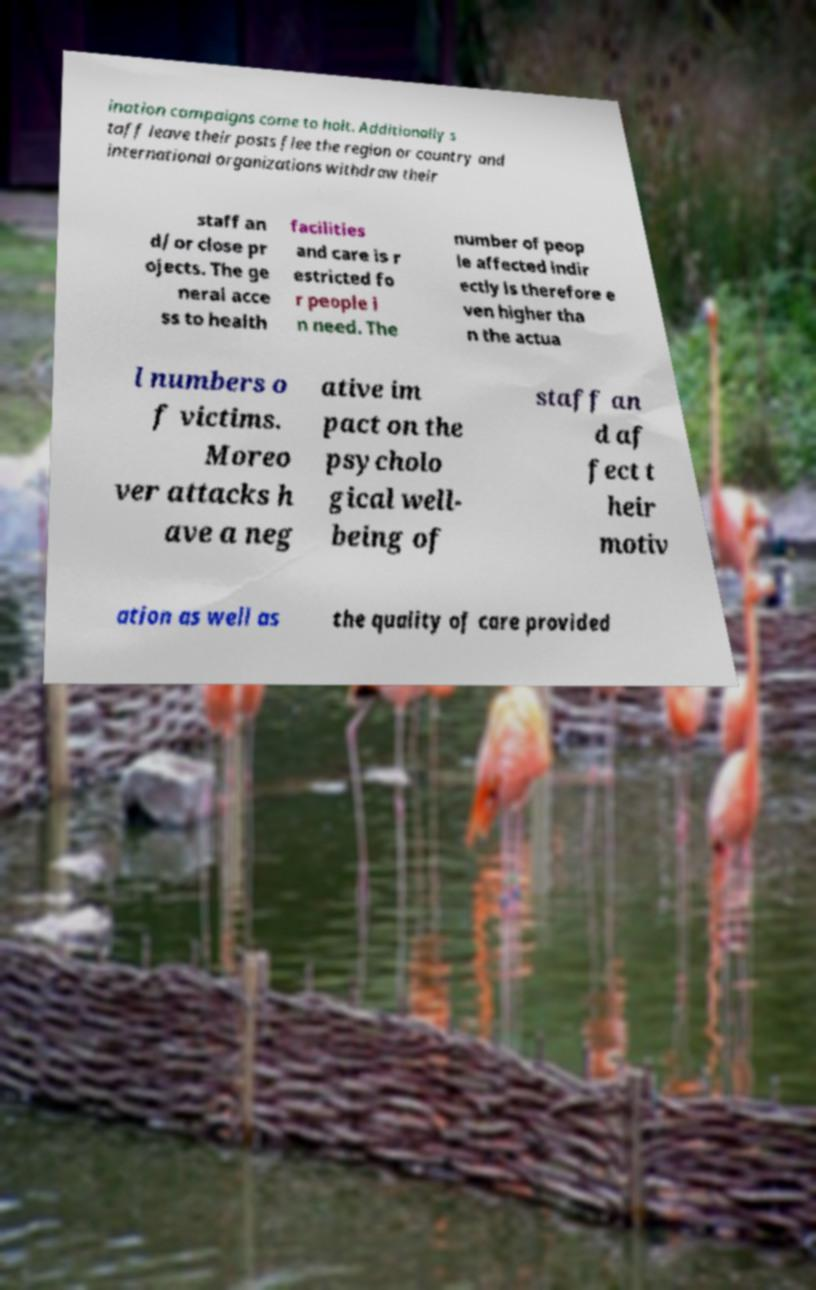Could you extract and type out the text from this image? ination campaigns come to halt. Additionally s taff leave their posts flee the region or country and international organizations withdraw their staff an d/ or close pr ojects. The ge neral acce ss to health facilities and care is r estricted fo r people i n need. The number of peop le affected indir ectly is therefore e ven higher tha n the actua l numbers o f victims. Moreo ver attacks h ave a neg ative im pact on the psycholo gical well- being of staff an d af fect t heir motiv ation as well as the quality of care provided 